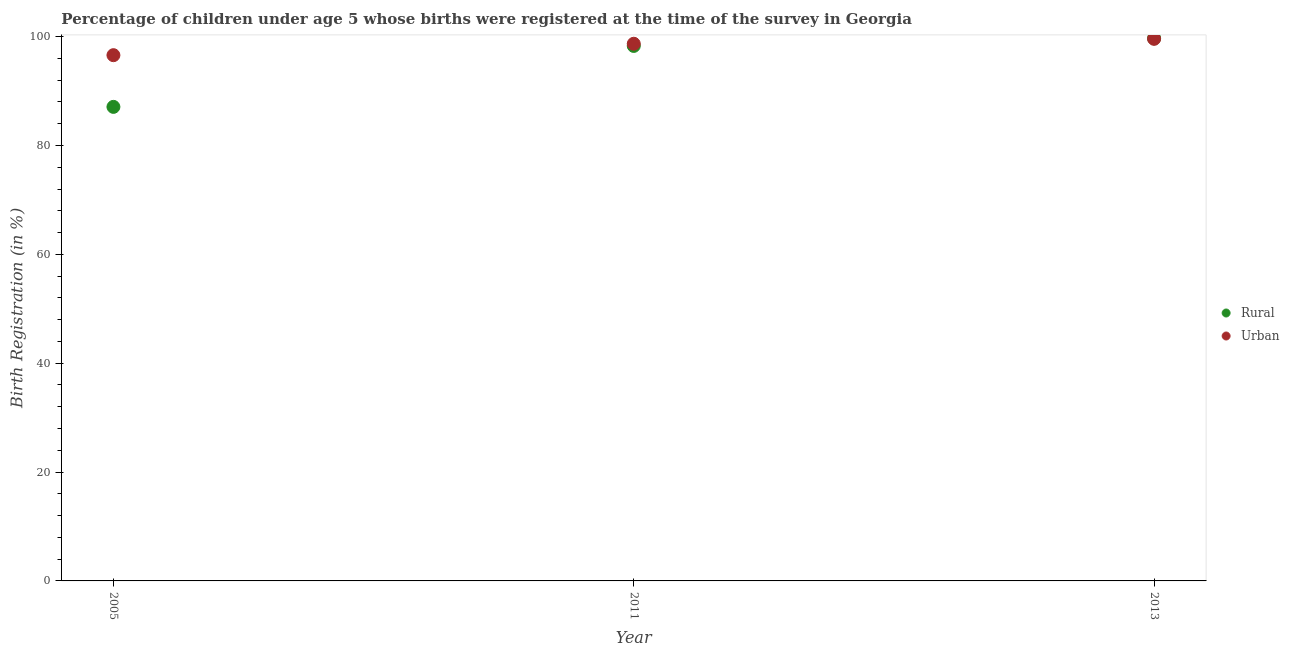Is the number of dotlines equal to the number of legend labels?
Your answer should be compact. Yes. What is the urban birth registration in 2005?
Provide a short and direct response. 96.6. Across all years, what is the maximum rural birth registration?
Offer a very short reply. 99.7. Across all years, what is the minimum rural birth registration?
Offer a very short reply. 87.1. What is the total rural birth registration in the graph?
Offer a terse response. 285.1. What is the difference between the rural birth registration in 2005 and that in 2013?
Your answer should be very brief. -12.6. What is the difference between the urban birth registration in 2011 and the rural birth registration in 2013?
Give a very brief answer. -1. What is the average urban birth registration per year?
Make the answer very short. 98.3. In the year 2011, what is the difference between the urban birth registration and rural birth registration?
Your answer should be very brief. 0.4. In how many years, is the urban birth registration greater than 68 %?
Your answer should be very brief. 3. What is the ratio of the urban birth registration in 2005 to that in 2013?
Keep it short and to the point. 0.97. What is the difference between the highest and the second highest rural birth registration?
Keep it short and to the point. 1.4. What is the difference between the highest and the lowest rural birth registration?
Your answer should be compact. 12.6. In how many years, is the rural birth registration greater than the average rural birth registration taken over all years?
Offer a terse response. 2. Is the sum of the rural birth registration in 2011 and 2013 greater than the maximum urban birth registration across all years?
Offer a very short reply. Yes. Does the rural birth registration monotonically increase over the years?
Provide a succinct answer. Yes. How many years are there in the graph?
Make the answer very short. 3. How are the legend labels stacked?
Make the answer very short. Vertical. What is the title of the graph?
Provide a short and direct response. Percentage of children under age 5 whose births were registered at the time of the survey in Georgia. Does "Quasi money growth" appear as one of the legend labels in the graph?
Offer a terse response. No. What is the label or title of the X-axis?
Your answer should be very brief. Year. What is the label or title of the Y-axis?
Make the answer very short. Birth Registration (in %). What is the Birth Registration (in %) in Rural in 2005?
Offer a very short reply. 87.1. What is the Birth Registration (in %) in Urban in 2005?
Give a very brief answer. 96.6. What is the Birth Registration (in %) of Rural in 2011?
Your answer should be very brief. 98.3. What is the Birth Registration (in %) in Urban in 2011?
Your answer should be compact. 98.7. What is the Birth Registration (in %) of Rural in 2013?
Provide a succinct answer. 99.7. What is the Birth Registration (in %) in Urban in 2013?
Your answer should be very brief. 99.6. Across all years, what is the maximum Birth Registration (in %) of Rural?
Give a very brief answer. 99.7. Across all years, what is the maximum Birth Registration (in %) of Urban?
Your response must be concise. 99.6. Across all years, what is the minimum Birth Registration (in %) of Rural?
Give a very brief answer. 87.1. Across all years, what is the minimum Birth Registration (in %) of Urban?
Your answer should be very brief. 96.6. What is the total Birth Registration (in %) in Rural in the graph?
Provide a succinct answer. 285.1. What is the total Birth Registration (in %) of Urban in the graph?
Keep it short and to the point. 294.9. What is the difference between the Birth Registration (in %) of Rural in 2005 and that in 2011?
Your answer should be compact. -11.2. What is the difference between the Birth Registration (in %) in Rural in 2011 and that in 2013?
Your answer should be very brief. -1.4. What is the difference between the Birth Registration (in %) in Urban in 2011 and that in 2013?
Keep it short and to the point. -0.9. What is the difference between the Birth Registration (in %) in Rural in 2005 and the Birth Registration (in %) in Urban in 2013?
Keep it short and to the point. -12.5. What is the difference between the Birth Registration (in %) of Rural in 2011 and the Birth Registration (in %) of Urban in 2013?
Keep it short and to the point. -1.3. What is the average Birth Registration (in %) of Rural per year?
Your answer should be compact. 95.03. What is the average Birth Registration (in %) of Urban per year?
Give a very brief answer. 98.3. What is the ratio of the Birth Registration (in %) of Rural in 2005 to that in 2011?
Make the answer very short. 0.89. What is the ratio of the Birth Registration (in %) of Urban in 2005 to that in 2011?
Your answer should be very brief. 0.98. What is the ratio of the Birth Registration (in %) of Rural in 2005 to that in 2013?
Offer a terse response. 0.87. What is the ratio of the Birth Registration (in %) of Urban in 2005 to that in 2013?
Your answer should be very brief. 0.97. What is the ratio of the Birth Registration (in %) of Rural in 2011 to that in 2013?
Ensure brevity in your answer.  0.99. What is the difference between the highest and the second highest Birth Registration (in %) in Urban?
Offer a terse response. 0.9. What is the difference between the highest and the lowest Birth Registration (in %) in Rural?
Your response must be concise. 12.6. 